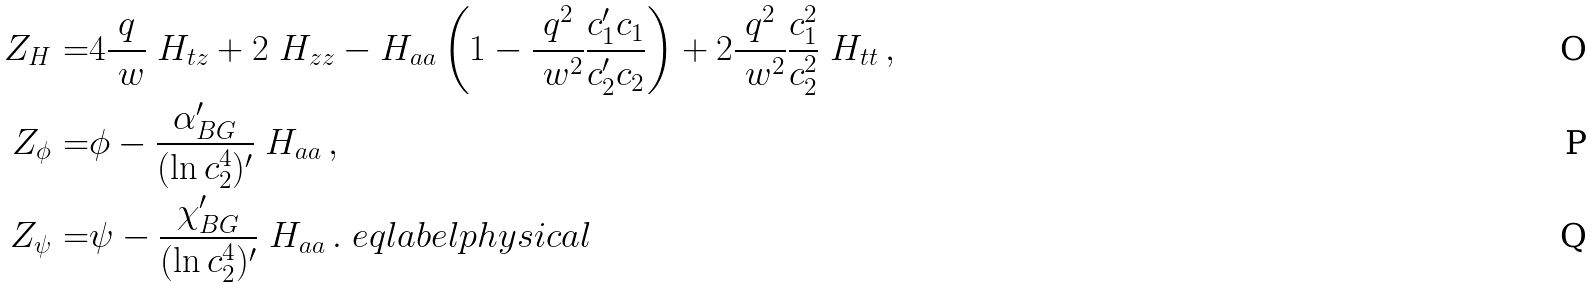<formula> <loc_0><loc_0><loc_500><loc_500>Z _ { H } = & 4 \frac { q } { \ w } \ H _ { t z } + 2 \ H _ { z z } - H _ { a a } \left ( 1 - \frac { q ^ { 2 } } { \ w ^ { 2 } } \frac { c _ { 1 } ^ { \prime } c _ { 1 } } { c _ { 2 } ^ { \prime } c _ { 2 } } \right ) + 2 \frac { q ^ { 2 } } { \ w ^ { 2 } } \frac { c _ { 1 } ^ { 2 } } { c _ { 2 } ^ { 2 } } \ H _ { t t } \, , \\ Z _ { \phi } = & \phi - \frac { \alpha _ { B G } ^ { \prime } } { ( \ln c _ { 2 } ^ { 4 } ) ^ { \prime } } \ H _ { a a } \, , \\ Z _ { \psi } = & \psi - \frac { \chi _ { B G } ^ { \prime } } { ( \ln c _ { 2 } ^ { 4 } ) ^ { \prime } } \ H _ { a a } \, . \ e q l a b e l { p h y s i c a l }</formula> 